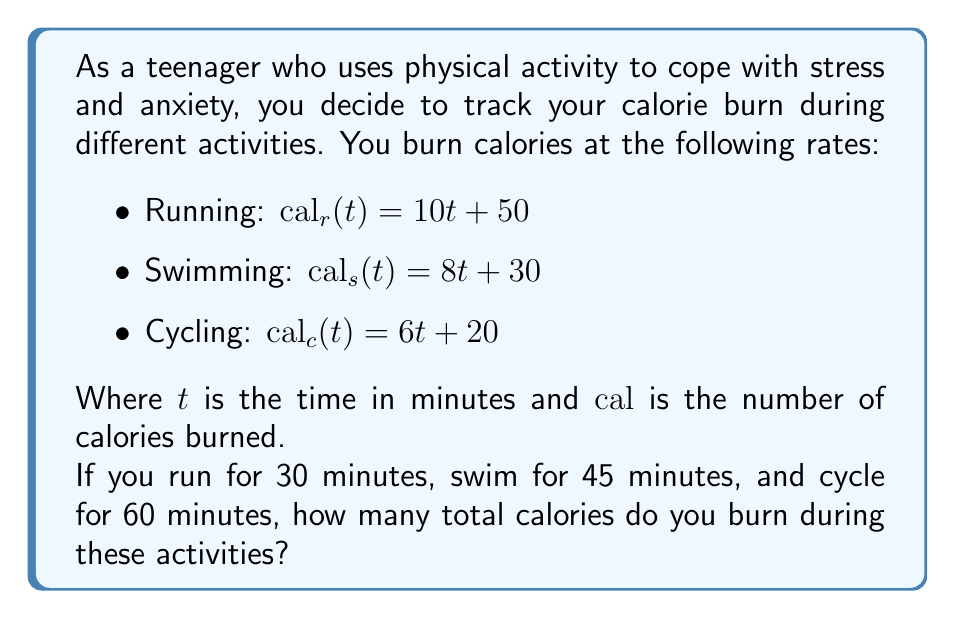What is the answer to this math problem? Let's break this down step-by-step:

1) For running:
   - Time $t_r = 30$ minutes
   - Calories burned: $cal_r(30) = 10(30) + 50 = 300 + 50 = 350$ calories

2) For swimming:
   - Time $t_s = 45$ minutes
   - Calories burned: $cal_s(45) = 8(45) + 30 = 360 + 30 = 390$ calories

3) For cycling:
   - Time $t_c = 60$ minutes
   - Calories burned: $cal_c(60) = 6(60) + 20 = 360 + 20 = 380$ calories

4) Total calories burned:
   $total\_cal = cal_r(30) + cal_s(45) + cal_c(60)$
   $total\_cal = 350 + 390 + 380 = 1120$ calories

Therefore, the total number of calories burned during these activities is 1120.
Answer: 1120 calories 